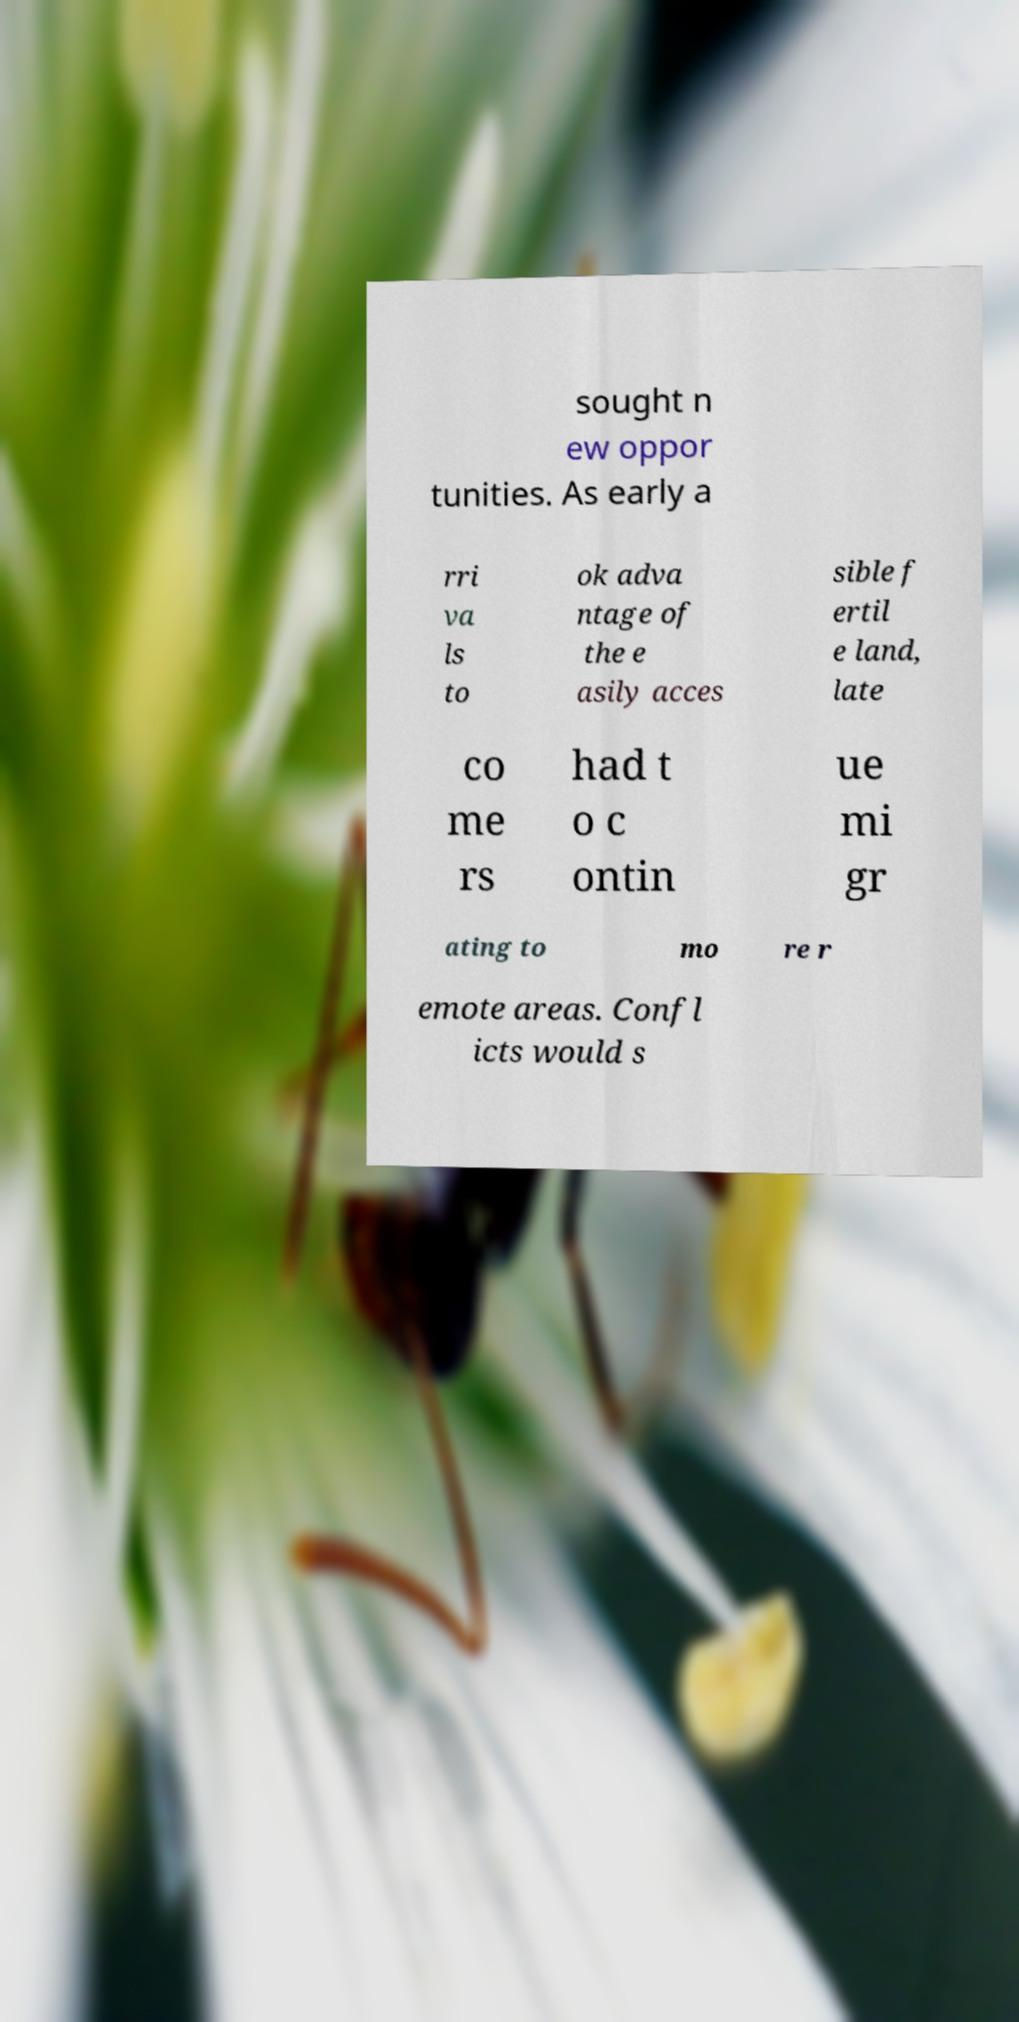There's text embedded in this image that I need extracted. Can you transcribe it verbatim? sought n ew oppor tunities. As early a rri va ls to ok adva ntage of the e asily acces sible f ertil e land, late co me rs had t o c ontin ue mi gr ating to mo re r emote areas. Confl icts would s 